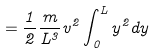Convert formula to latex. <formula><loc_0><loc_0><loc_500><loc_500>= \frac { 1 } { 2 } \frac { m } { L ^ { 3 } } v ^ { 2 } \int _ { 0 } ^ { L } y ^ { 2 } d y</formula> 